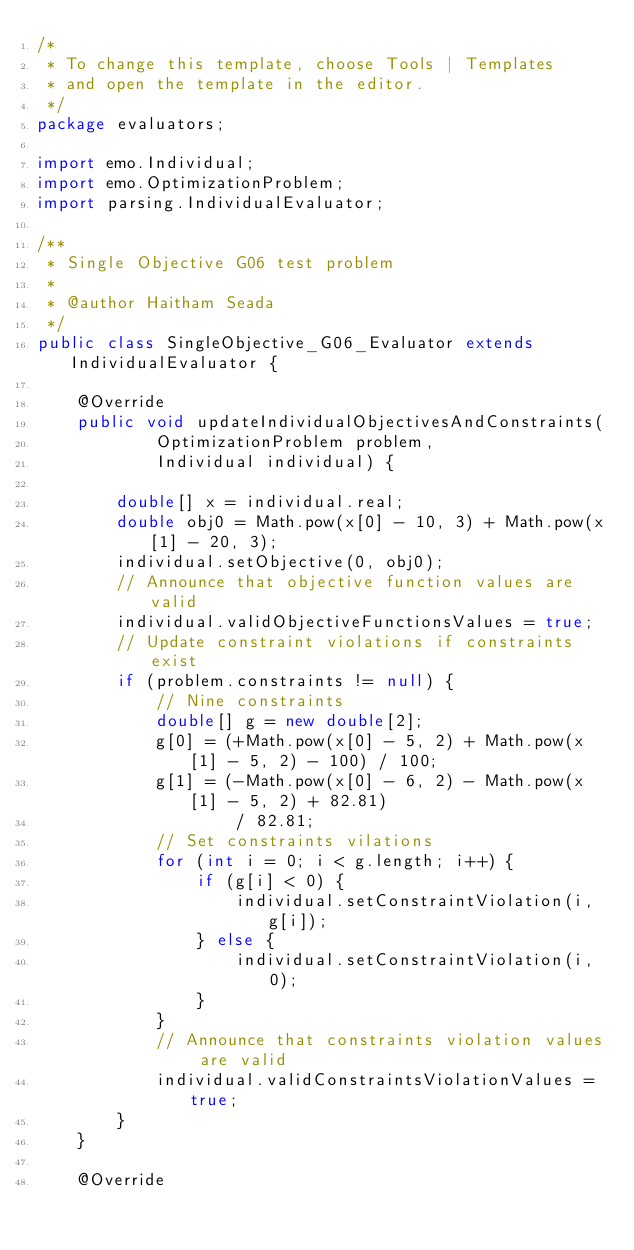<code> <loc_0><loc_0><loc_500><loc_500><_Java_>/*
 * To change this template, choose Tools | Templates
 * and open the template in the editor.
 */
package evaluators;

import emo.Individual;
import emo.OptimizationProblem;
import parsing.IndividualEvaluator;

/**
 * Single Objective G06 test problem
 *
 * @author Haitham Seada
 */
public class SingleObjective_G06_Evaluator extends IndividualEvaluator {

    @Override
    public void updateIndividualObjectivesAndConstraints(
            OptimizationProblem problem,
            Individual individual) {

        double[] x = individual.real;
        double obj0 = Math.pow(x[0] - 10, 3) + Math.pow(x[1] - 20, 3);
        individual.setObjective(0, obj0);
        // Announce that objective function values are valid
        individual.validObjectiveFunctionsValues = true;
        // Update constraint violations if constraints exist
        if (problem.constraints != null) {
            // Nine constraints
            double[] g = new double[2];
            g[0] = (+Math.pow(x[0] - 5, 2) + Math.pow(x[1] - 5, 2) - 100) / 100;
            g[1] = (-Math.pow(x[0] - 6, 2) - Math.pow(x[1] - 5, 2) + 82.81)
                    / 82.81;
            // Set constraints vilations
            for (int i = 0; i < g.length; i++) {
                if (g[i] < 0) {
                    individual.setConstraintViolation(i, g[i]);
                } else {
                    individual.setConstraintViolation(i, 0);
                }
            }
            // Announce that constraints violation values are valid
            individual.validConstraintsViolationValues = true;
        }
    }

    @Override</code> 